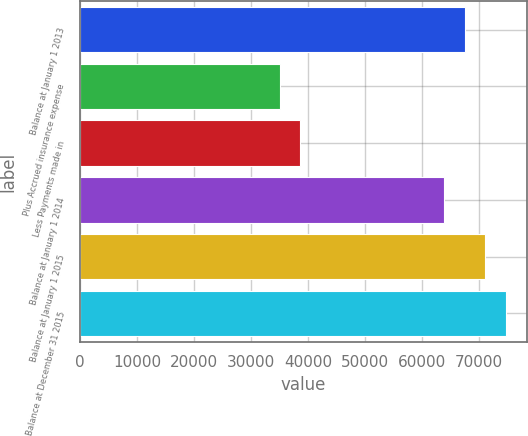<chart> <loc_0><loc_0><loc_500><loc_500><bar_chart><fcel>Balance at January 1 2013<fcel>Plus Accrued insurance expense<fcel>Less Payments made in<fcel>Balance at January 1 2014<fcel>Balance at January 1 2015<fcel>Balance at December 31 2015<nl><fcel>67412.2<fcel>34975.2<fcel>38589.4<fcel>63798<fcel>71026.4<fcel>74640.6<nl></chart> 